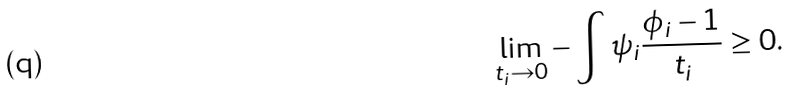<formula> <loc_0><loc_0><loc_500><loc_500>\lim _ { t _ { i } \rightarrow 0 } - \int \psi _ { i } \frac { \phi _ { i } - 1 } { t _ { i } } \geq 0 .</formula> 